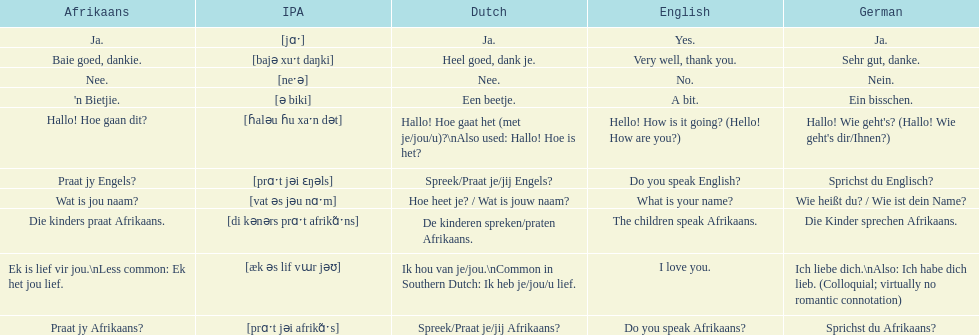How do you say "do you speak afrikaans?" in afrikaans? Praat jy Afrikaans?. 